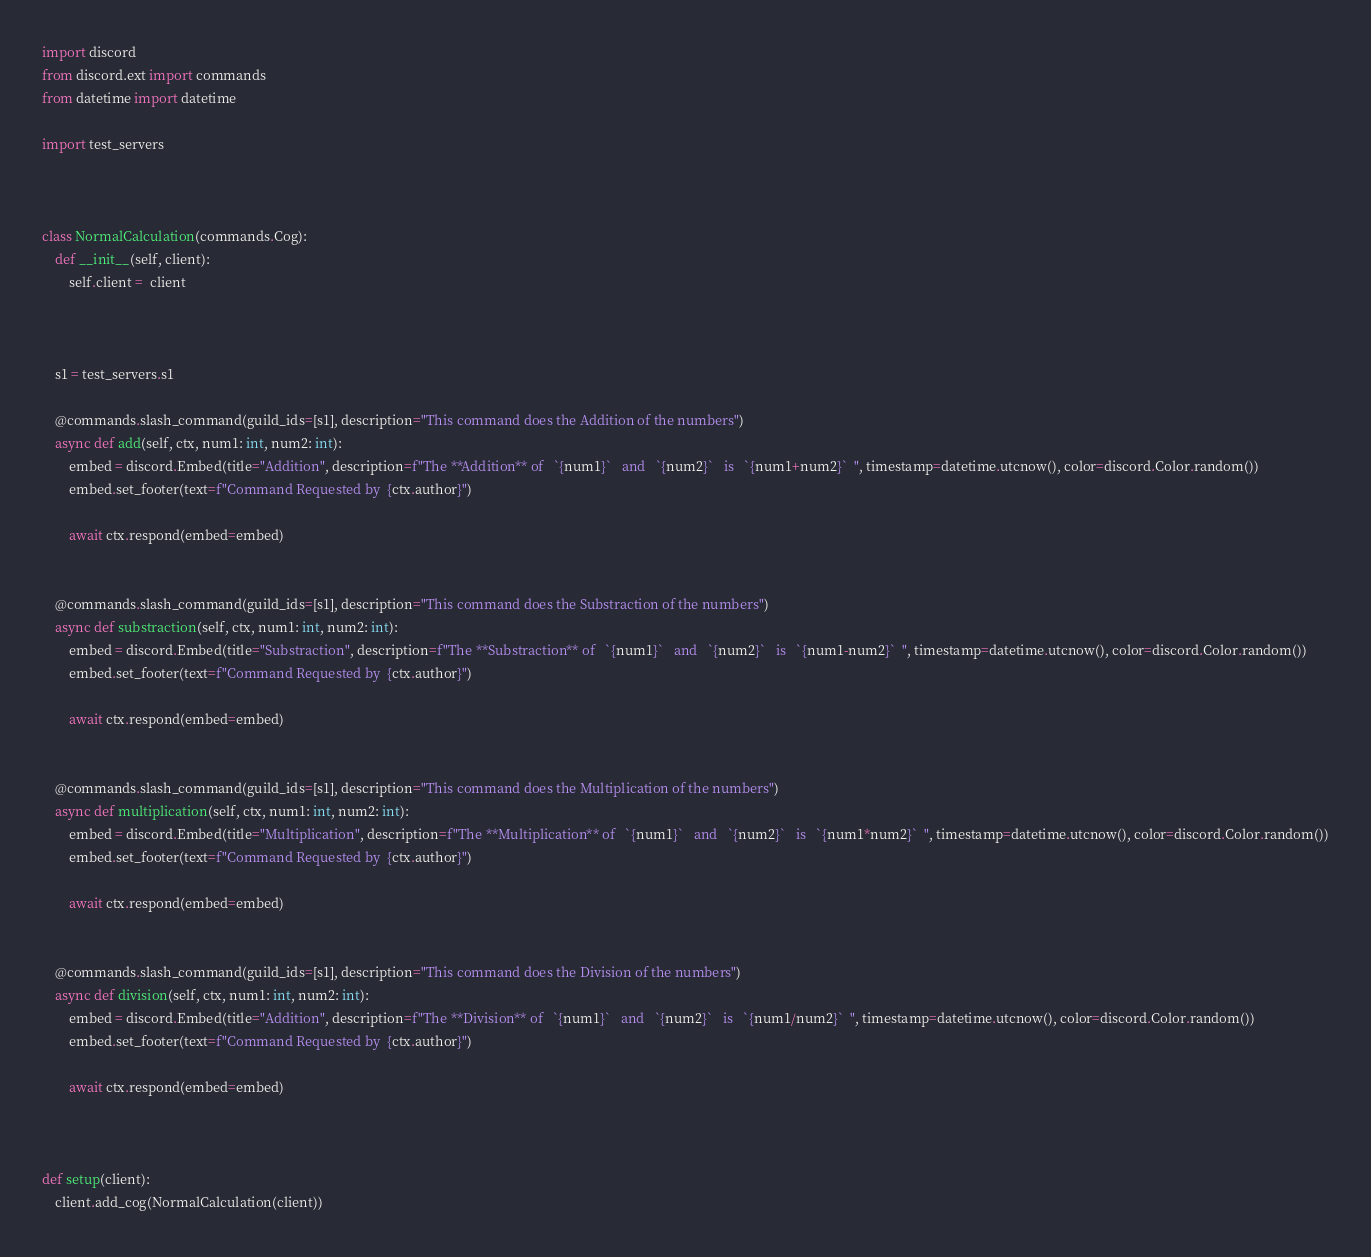Convert code to text. <code><loc_0><loc_0><loc_500><loc_500><_Python_>import discord
from discord.ext import commands
from datetime import datetime

import test_servers



class NormalCalculation(commands.Cog):
    def __init__(self, client):
        self.client =  client



    s1 = test_servers.s1

    @commands.slash_command(guild_ids=[s1], description="This command does the Addition of the numbers")
    async def add(self, ctx, num1: int, num2: int):
        embed = discord.Embed(title="Addition", description=f"The **Addition** of   `{num1}`   and   `{num2}`   is   `{num1+num2}`  ", timestamp=datetime.utcnow(), color=discord.Color.random())
        embed.set_footer(text=f"Command Requested by  {ctx.author}")

        await ctx.respond(embed=embed)


    @commands.slash_command(guild_ids=[s1], description="This command does the Substraction of the numbers")
    async def substraction(self, ctx, num1: int, num2: int):
        embed = discord.Embed(title="Substraction", description=f"The **Substraction** of   `{num1}`   and   `{num2}`   is   `{num1-num2}`  ", timestamp=datetime.utcnow(), color=discord.Color.random())
        embed.set_footer(text=f"Command Requested by  {ctx.author}")

        await ctx.respond(embed=embed)


    @commands.slash_command(guild_ids=[s1], description="This command does the Multiplication of the numbers")
    async def multiplication(self, ctx, num1: int, num2: int):
        embed = discord.Embed(title="Multiplication", description=f"The **Multiplication** of   `{num1}`   and   `{num2}`   is   `{num1*num2}`  ", timestamp=datetime.utcnow(), color=discord.Color.random())
        embed.set_footer(text=f"Command Requested by  {ctx.author}")

        await ctx.respond(embed=embed)


    @commands.slash_command(guild_ids=[s1], description="This command does the Division of the numbers")
    async def division(self, ctx, num1: int, num2: int):
        embed = discord.Embed(title="Addition", description=f"The **Division** of   `{num1}`   and   `{num2}`   is   `{num1/num2}`  ", timestamp=datetime.utcnow(), color=discord.Color.random())
        embed.set_footer(text=f"Command Requested by  {ctx.author}")

        await ctx.respond(embed=embed)



def setup(client):
    client.add_cog(NormalCalculation(client))
</code> 